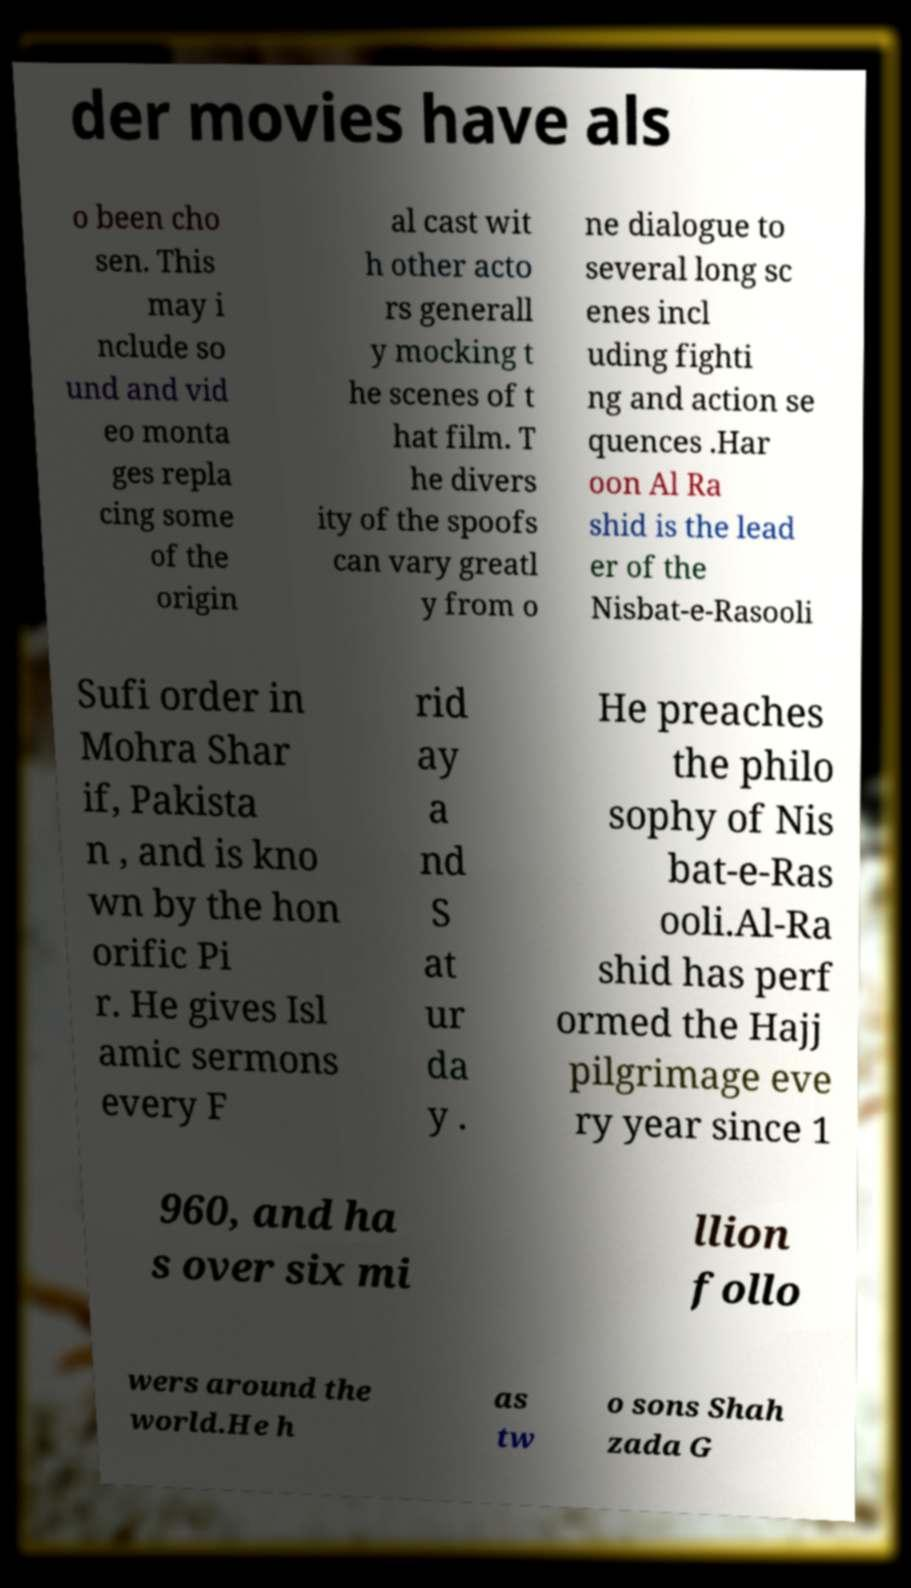Please identify and transcribe the text found in this image. der movies have als o been cho sen. This may i nclude so und and vid eo monta ges repla cing some of the origin al cast wit h other acto rs generall y mocking t he scenes of t hat film. T he divers ity of the spoofs can vary greatl y from o ne dialogue to several long sc enes incl uding fighti ng and action se quences .Har oon Al Ra shid is the lead er of the Nisbat-e-Rasooli Sufi order in Mohra Shar if, Pakista n , and is kno wn by the hon orific Pi r. He gives Isl amic sermons every F rid ay a nd S at ur da y . He preaches the philo sophy of Nis bat-e-Ras ooli.Al-Ra shid has perf ormed the Hajj pilgrimage eve ry year since 1 960, and ha s over six mi llion follo wers around the world.He h as tw o sons Shah zada G 